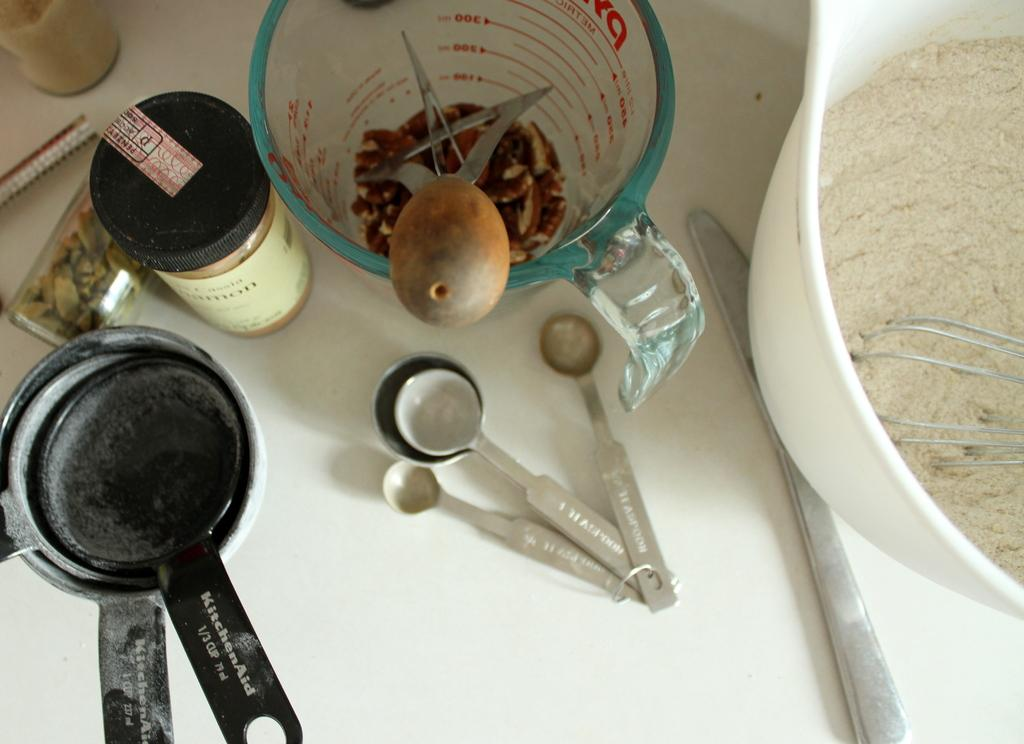What piece of furniture is present in the image? There is a table in the image. What is placed on the table? There is a bowl and spoons on the table. Is there any other object on the table? Yes, there is a bottle on the table. What month is depicted in the image? There is no indication of a specific month in the image. How many times has the invention been folded in the image? There is no invention present in the image, so it cannot be folded. 